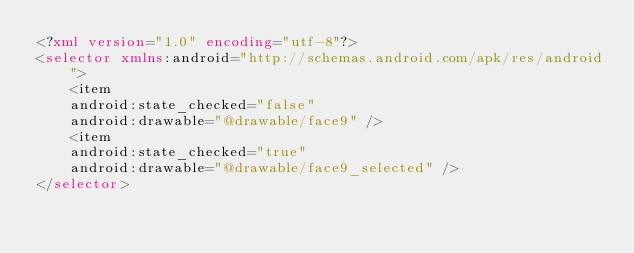Convert code to text. <code><loc_0><loc_0><loc_500><loc_500><_XML_><?xml version="1.0" encoding="utf-8"?>   
<selector xmlns:android="http://schemas.android.com/apk/res/android">   
    <item   
    android:state_checked="false"   
    android:drawable="@drawable/face9" />   
    <item   
    android:state_checked="true"   
    android:drawable="@drawable/face9_selected" />   
</selector>   </code> 